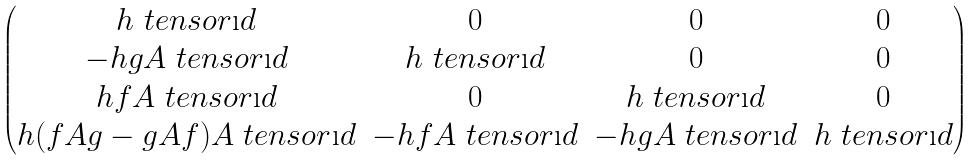Convert formula to latex. <formula><loc_0><loc_0><loc_500><loc_500>\begin{pmatrix} h \ t e n s o r \i d & 0 & 0 & 0 \\ - h g A \ t e n s o r \i d & h \ t e n s o r \i d & 0 & 0 \\ h f A \ t e n s o r \i d & 0 & h \ t e n s o r \i d & 0 \\ h ( f A g - g A f ) A \ t e n s o r \i d & - h f A \ t e n s o r \i d & - h g A \ t e n s o r \i d & h \ t e n s o r \i d \end{pmatrix}</formula> 